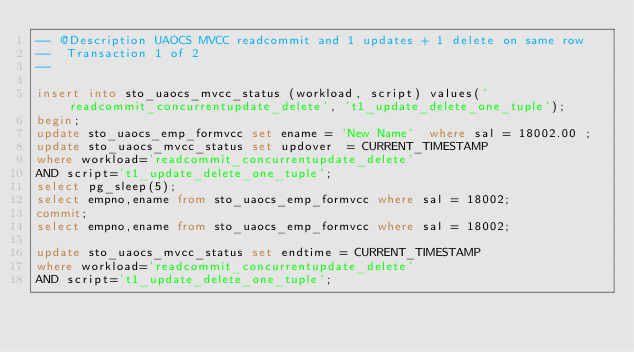Convert code to text. <code><loc_0><loc_0><loc_500><loc_500><_SQL_>-- @Description UAOCS MVCC readcommit and 1 updates + 1 delete on same row
--  Transaction 1 of 2
-- 

insert into sto_uaocs_mvcc_status (workload, script) values('readcommit_concurrentupdate_delete', 't1_update_delete_one_tuple');
begin;
update sto_uaocs_emp_formvcc set ename = 'New Name'  where sal = 18002.00 ;
update sto_uaocs_mvcc_status set updover  = CURRENT_TIMESTAMP 
where workload='readcommit_concurrentupdate_delete' 
AND script='t1_update_delete_one_tuple';
select pg_sleep(5);
select empno,ename from sto_uaocs_emp_formvcc where sal = 18002;
commit;
select empno,ename from sto_uaocs_emp_formvcc where sal = 18002;

update sto_uaocs_mvcc_status set endtime = CURRENT_TIMESTAMP 
where workload='readcommit_concurrentupdate_delete' 
AND script='t1_update_delete_one_tuple';

</code> 